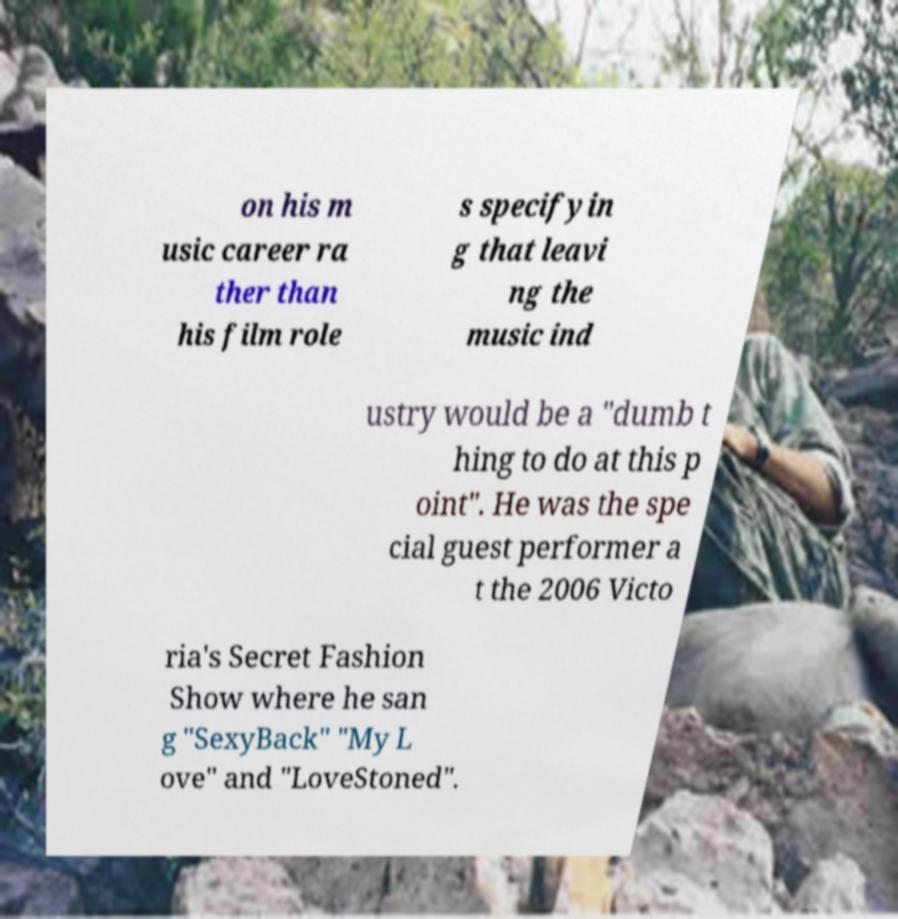Please read and relay the text visible in this image. What does it say? on his m usic career ra ther than his film role s specifyin g that leavi ng the music ind ustry would be a "dumb t hing to do at this p oint". He was the spe cial guest performer a t the 2006 Victo ria's Secret Fashion Show where he san g "SexyBack" "My L ove" and "LoveStoned". 